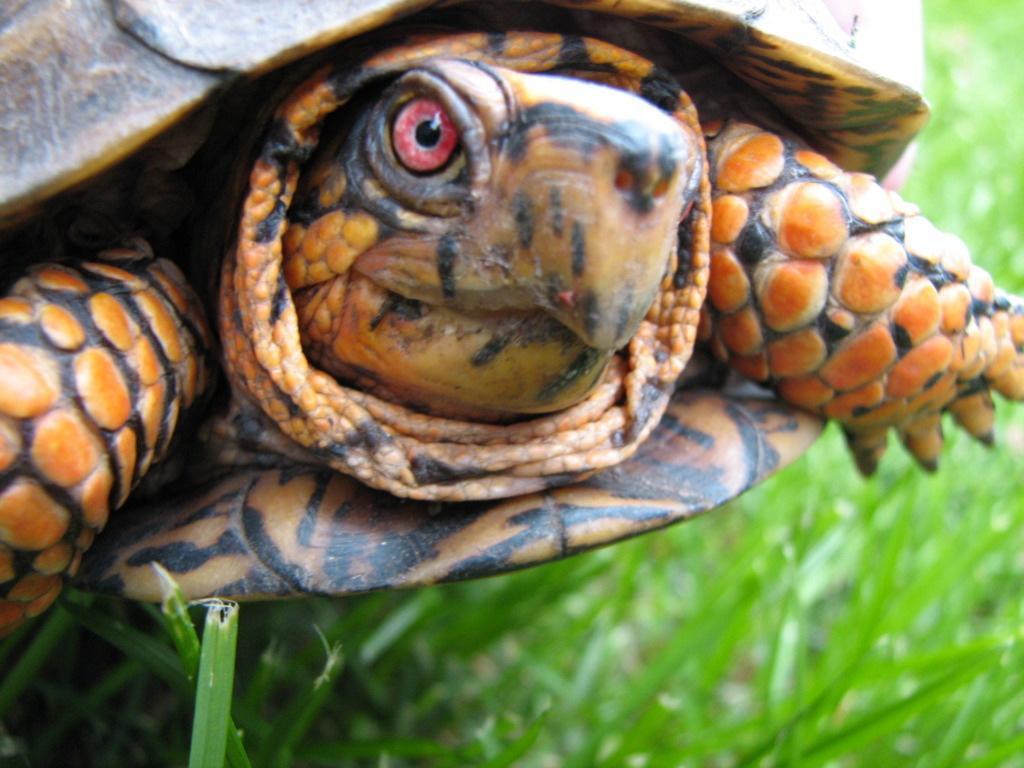Can you describe this image briefly? In this image we can see tortoise on the grass. 